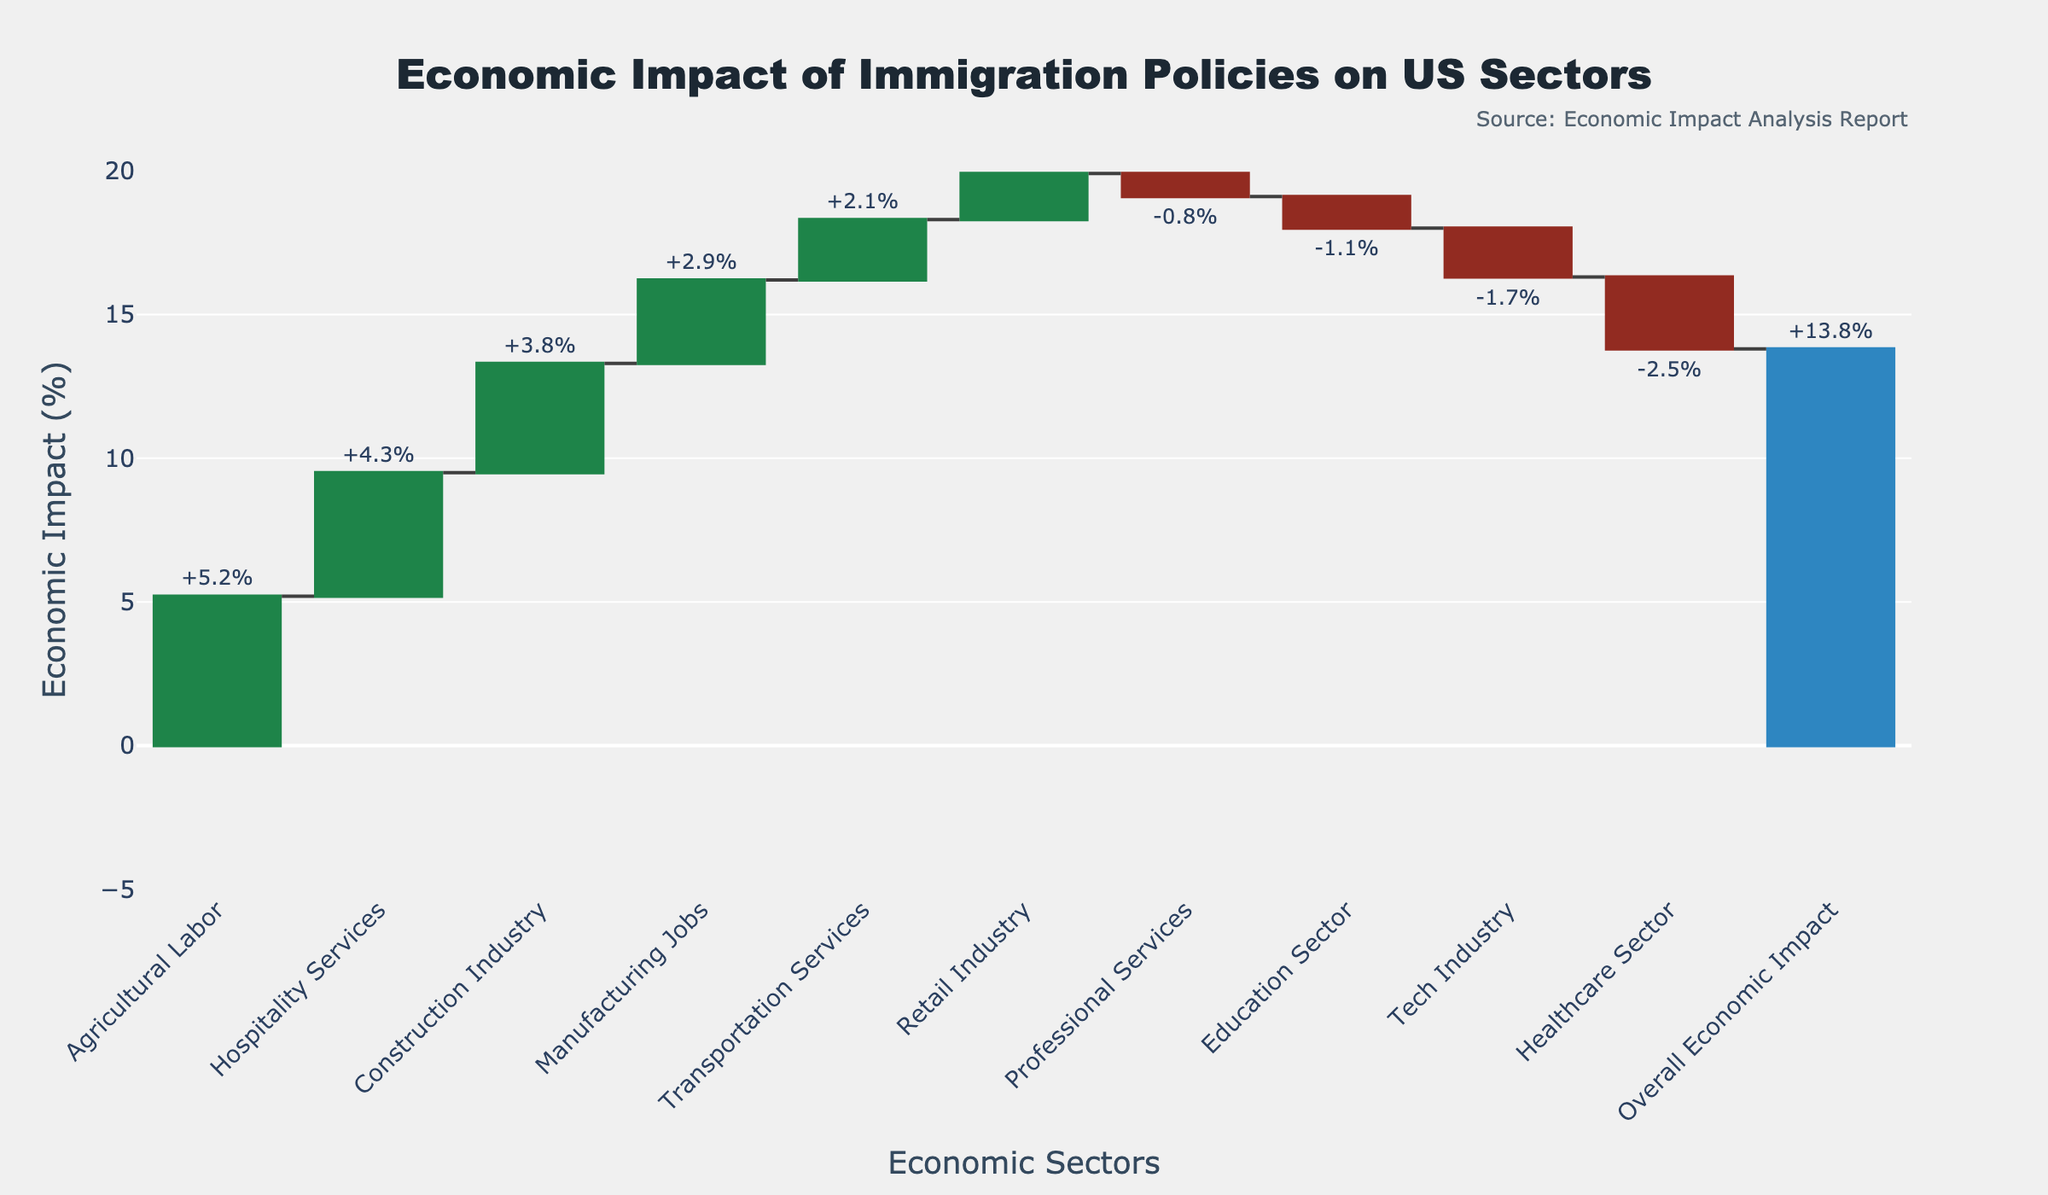Which sector experiences the highest positive impact from immigration policies? Looking at the waterfall chart, the "Agricultural Labor" sector has the highest positive value at +5.2%.
Answer: Agricultural Labor What is the overall economic impact of the immigration policies? The overall economic impact is given as a total bar at the end of the chart, showing a value of +13.8%.
Answer: +13.8% How many sectors show a negative impact due to immigration policies? By counting the negative values in the chart, three sectors show a negative impact: Healthcare Sector, Tech Industry, and Education Sector.
Answer: Three What is the difference in economic impact between the Hospitality Services and Retail Industry sectors? Hospitality Services has a value of +4.3% and Retail Industry has a value of +1.6%. Subtracting these gives a difference of 4.3% - 1.6% = 2.7%.
Answer: 2.7% Which sector experiences the largest negative impact from immigration policies? The "Healthcare Sector" shows the largest negative impact with a value of -2.5%.
Answer: Healthcare Sector How does the economic impact on Construction Industry compare to the Tech Industry? The Construction Industry has a value of +3.8% while the Tech Industry has a value of -1.7%. The Construction Industry has a greater positive impact.
Answer: Construction Industry has a greater positive impact What is the combined positive impact of the Agricultural Labor and Hospitality Services sectors? Agricultural Labor has a value of +5.2% and Hospitality Services has a value of +4.3%. Adding these gives a combined impact of 5.2% + 4.3% = 9.5%.
Answer: 9.5% Is the economic impact on the Manufacturing Jobs sector higher or lower than the Transportation Services sector? The Manufacturing Jobs sector has a value of +2.9%, which is higher compared to the +2.1% impact of the Transportation Services sector.
Answer: Higher How many sectors have a positive impact greater than 4%? By observing the chart, two sectors have a positive impact greater than 4%: Agricultural Labor (+5.2%) and Hospitality Services (+4.3%).
Answer: Two What is the average economic impact across all sectors excluding the "Overall Economic Impact"? Adding all the sector values: 5.2 + 3.8 + (-2.5) + (-1.7) + 4.3 + 2.9 + (-1.1) + 1.6 + 2.1 + (-0.8) = 13.8. There are 10 sectors, so the average is 13.8 / 10 = 1.38%.
Answer: 1.38% 